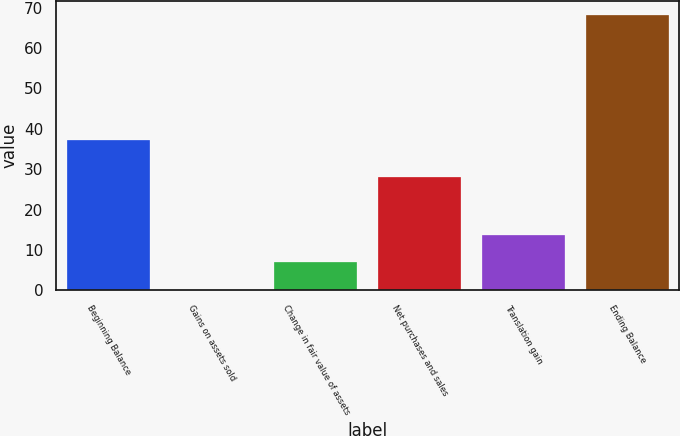Convert chart to OTSL. <chart><loc_0><loc_0><loc_500><loc_500><bar_chart><fcel>Beginning Balance<fcel>Gains on assets sold<fcel>Change in fair value of assets<fcel>Net purchases and sales<fcel>Translation gain<fcel>Ending Balance<nl><fcel>37.1<fcel>0.1<fcel>6.91<fcel>28.1<fcel>13.72<fcel>68.2<nl></chart> 